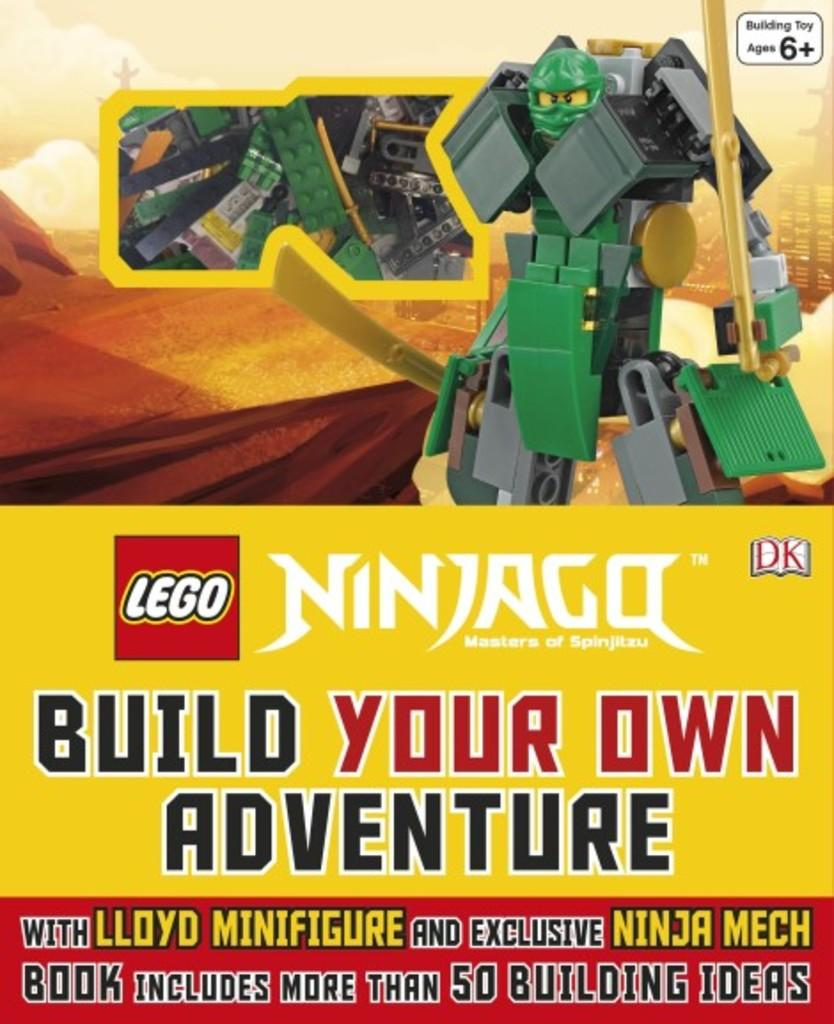Provide a one-sentence caption for the provided image. A Ninjago build your own adventure set from Lego shows a warrior character on the front. 